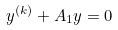<formula> <loc_0><loc_0><loc_500><loc_500>y ^ { ( k ) } + A _ { 1 } y = 0</formula> 